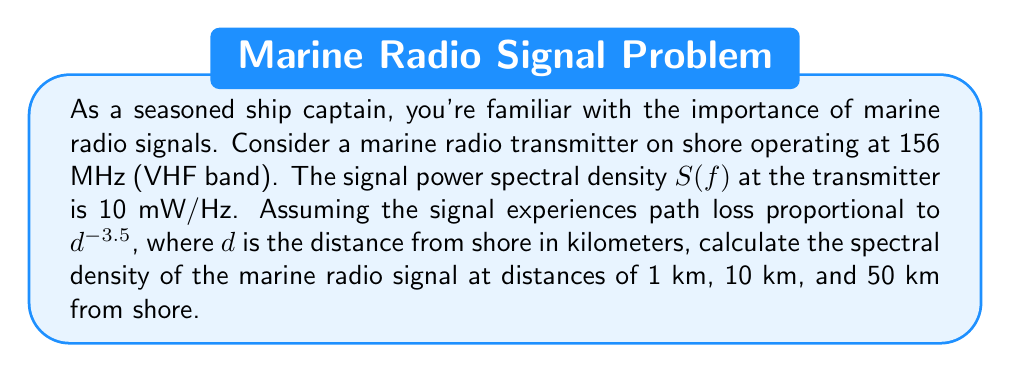What is the answer to this math problem? Let's approach this step-by-step:

1) The initial spectral density at the transmitter is $S_0(f) = 10$ mW/Hz.

2) The path loss is proportional to $d^{-3.5}$, where $d$ is the distance in km. This means the spectral density at distance $d$ is given by:

   $$S(f,d) = S_0(f) \cdot d^{-3.5}$$

3) Let's calculate for each distance:

   a) At $d = 1$ km:
      $$S(f,1) = 10 \cdot 1^{-3.5} = 10 \text{ mW/Hz}$$

   b) At $d = 10$ km:
      $$S(f,10) = 10 \cdot 10^{-3.5} \approx 0.0316 \text{ mW/Hz}$$

   c) At $d = 50$ km:
      $$S(f,50) = 10 \cdot 50^{-3.5} \approx 0.00126 \text{ mW/Hz}$$

4) Converting to more appropriate units:
   At 10 km: $0.0316 \text{ mW/Hz} = 31.6 \text{ µW/Hz}$
   At 50 km: $0.00126 \text{ mW/Hz} = 1.26 \text{ µW/Hz}$
Answer: 1 km: 10 mW/Hz; 10 km: 31.6 µW/Hz; 50 km: 1.26 µW/Hz 